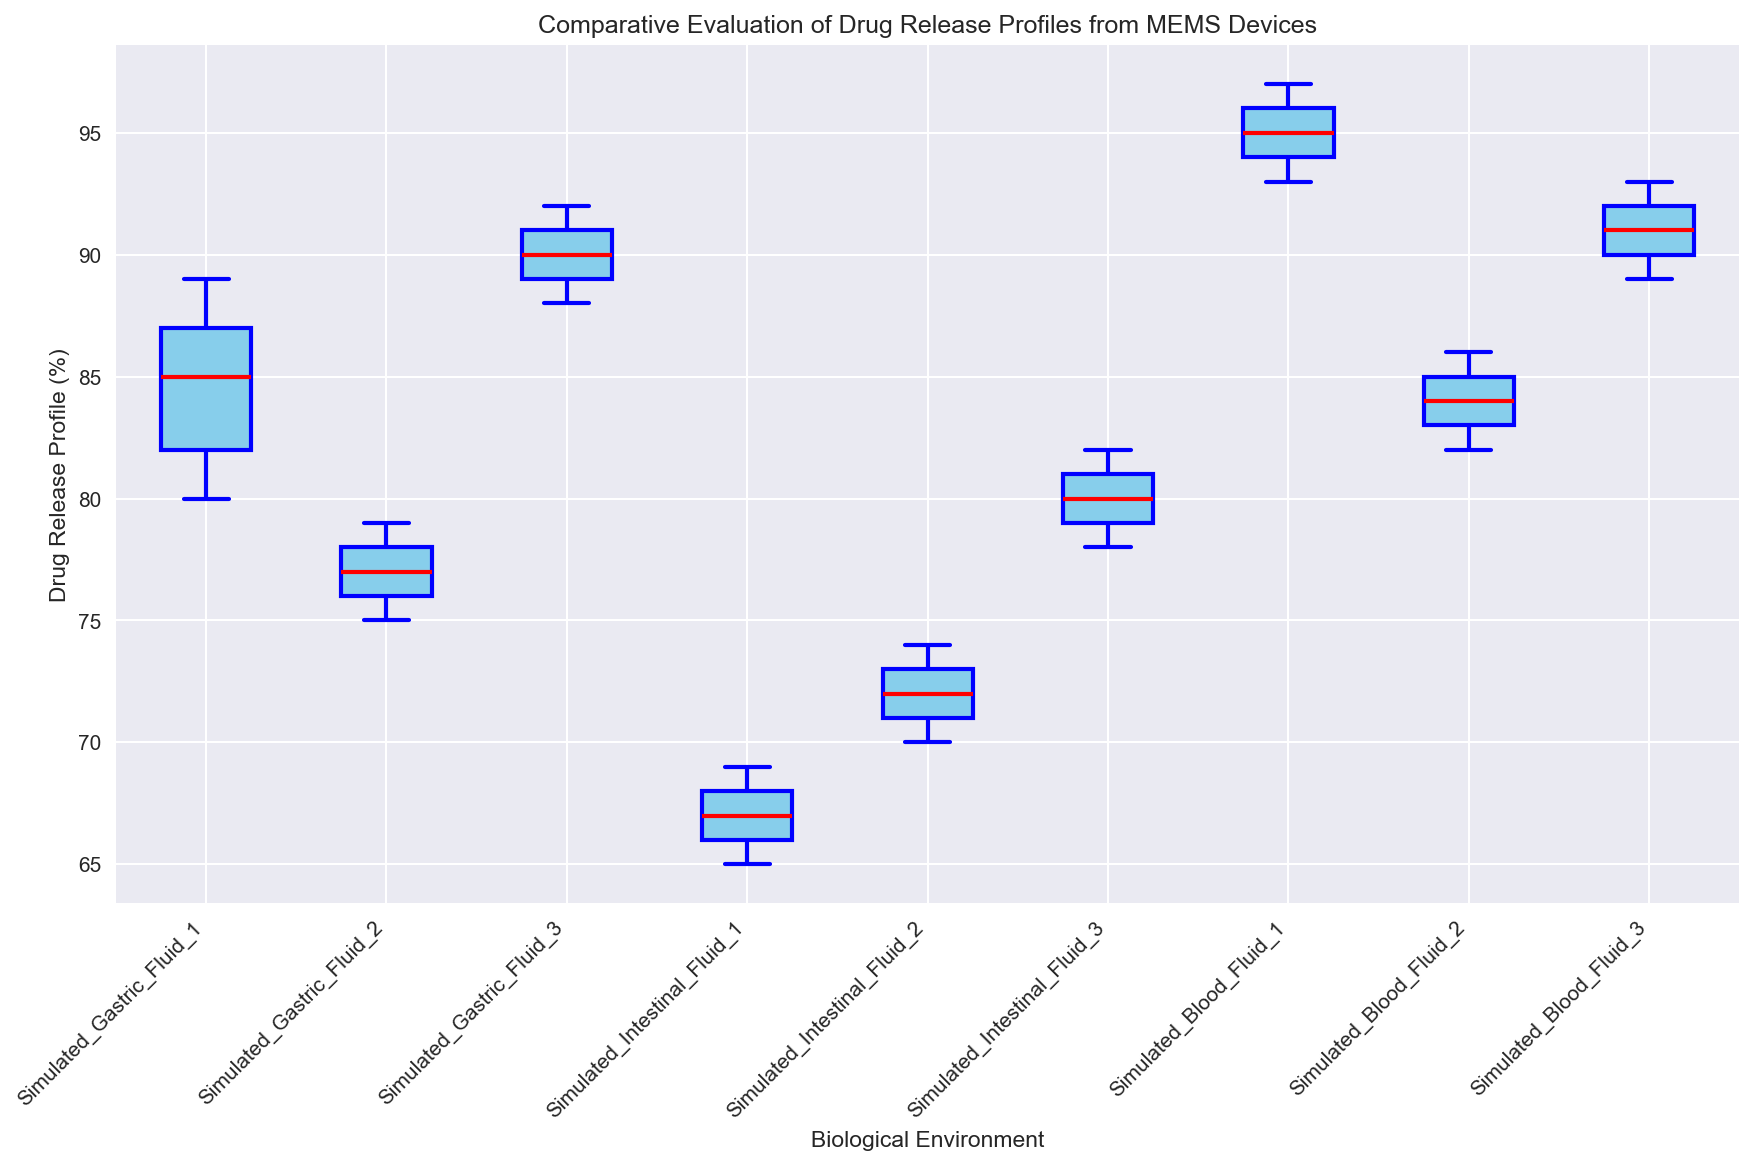Which biological environment has the highest median drug release profile? The boxplot's median line, which is marked in red, indicates the median drug release for each environment. By comparing these median lines, we can see which environment has the highest median value.
Answer: Simulated_Blood_Fluid_1 How does the median drug release for Simulated Gastric Fluid 2 compare to Simulated Intestinal Fluid 1? Look at the red median lines for both environments. Compare the position of these lines relative to each other to determine which is higher.
Answer: Higher What is the range of drug release profiles in Simulated Gastric Fluid 3? The range is calculated by finding the difference between the maximum and minimum values. The whiskers of the boxplot indicate these values.
Answer: 92-88 Which biological environment has the widest variability in drug release profiles? Variability can be assessed by looking at the size of the interquartile range (IQR), represented by the height of the box. The environment with the tallest box has the widest variability.
Answer: Simulated_Intestinal_Fluid_2 How do the drug release profiles of Simulated Blood Fluid 1 compare with Simulated Blood Fluid 3? Compare the red median lines and the height of the boxes. Both have similar medians and variabilities, but checking whiskers will show more details.
Answer: Similar Which environment shows the lowest outliers in drug release profiles? Outliers are represented as individual points outside the whiskers. Look for the smallest points farthest below the box.
Answer: Simulated_Intestinal_Fluid_1 What's the interquartile range (IQR) for Simulated Intestinal Fluid 3? The IQR is calculated as the difference between the third quartile (top of the box) and the first quartile (bottom of the box).
Answer: 82-79 Are there any overlapping interquartile ranges between any of the biological environments? Compare the height of each box (the interquartile ranges) and see if any boxes overlap with each other.
Answer: Yes Which environment has the smallest difference between its highest and lowest drug release profiles? The smallest range can be found by looking at the whiskers' extents and finding the difference between the maximum and minimum values of each environment.
Answer: Simulated_Gastric_Fluid_2 